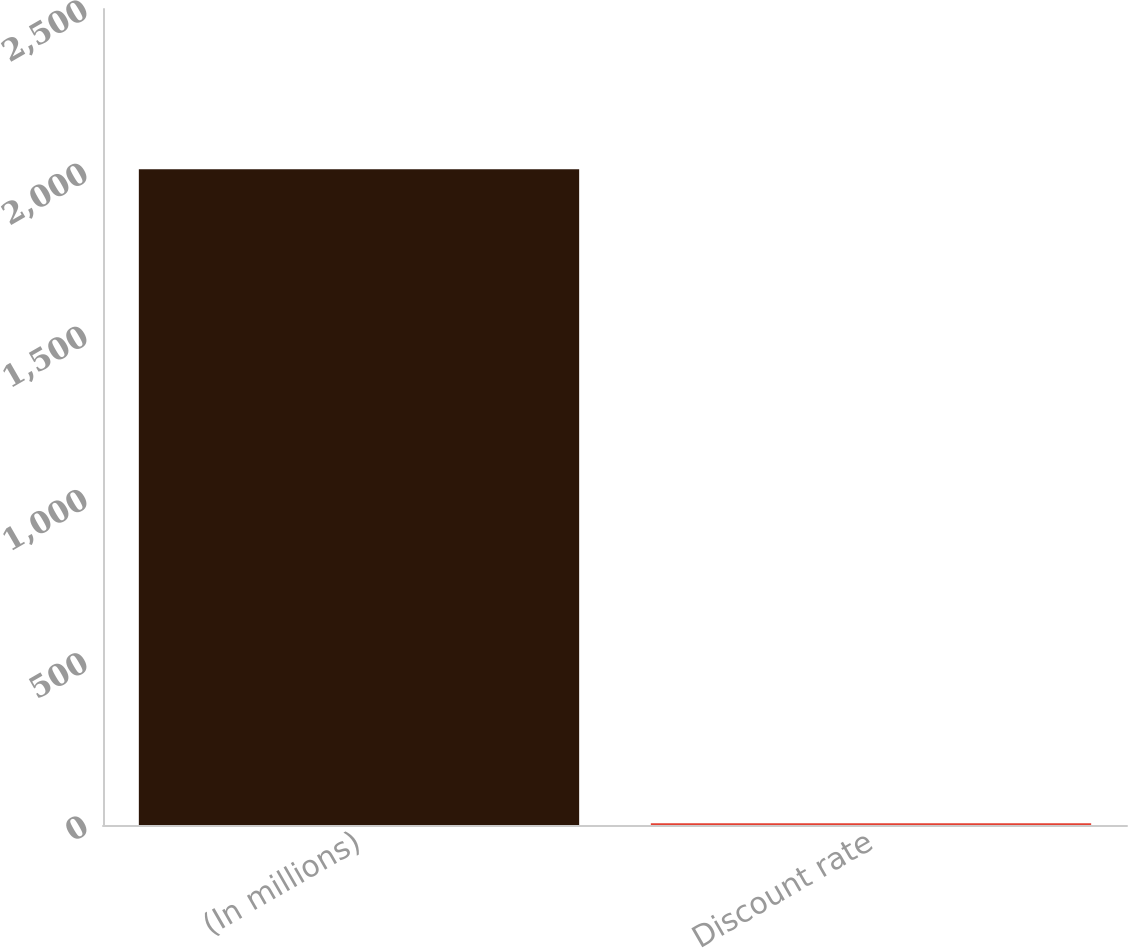<chart> <loc_0><loc_0><loc_500><loc_500><bar_chart><fcel>(In millions)<fcel>Discount rate<nl><fcel>2009<fcel>5.73<nl></chart> 